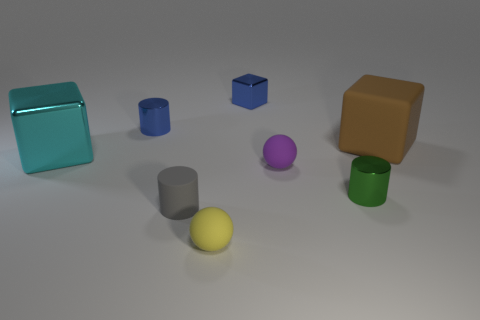What number of tiny objects are purple matte balls or brown metal things? In this image, there is one small, purple matte sphere. However, there are no objects that can be distinctly identified as brown metal things. Therefore, the total count of objects that fit the described characteristics is one. 